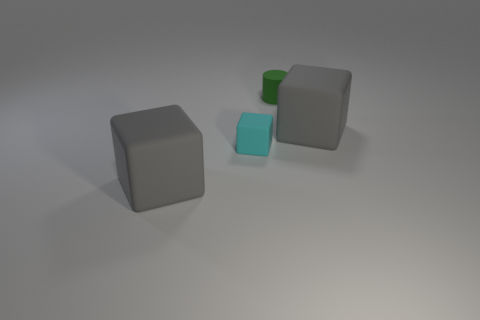Subtract all large blocks. How many blocks are left? 1 Subtract all cyan blocks. How many blocks are left? 2 Subtract all cylinders. How many objects are left? 3 Subtract 2 blocks. How many blocks are left? 1 Add 1 tiny metallic blocks. How many objects exist? 5 Subtract 0 blue cubes. How many objects are left? 4 Subtract all yellow cylinders. Subtract all cyan spheres. How many cylinders are left? 1 Subtract all brown cubes. How many gray cylinders are left? 0 Subtract all gray matte objects. Subtract all gray matte blocks. How many objects are left? 0 Add 3 green objects. How many green objects are left? 4 